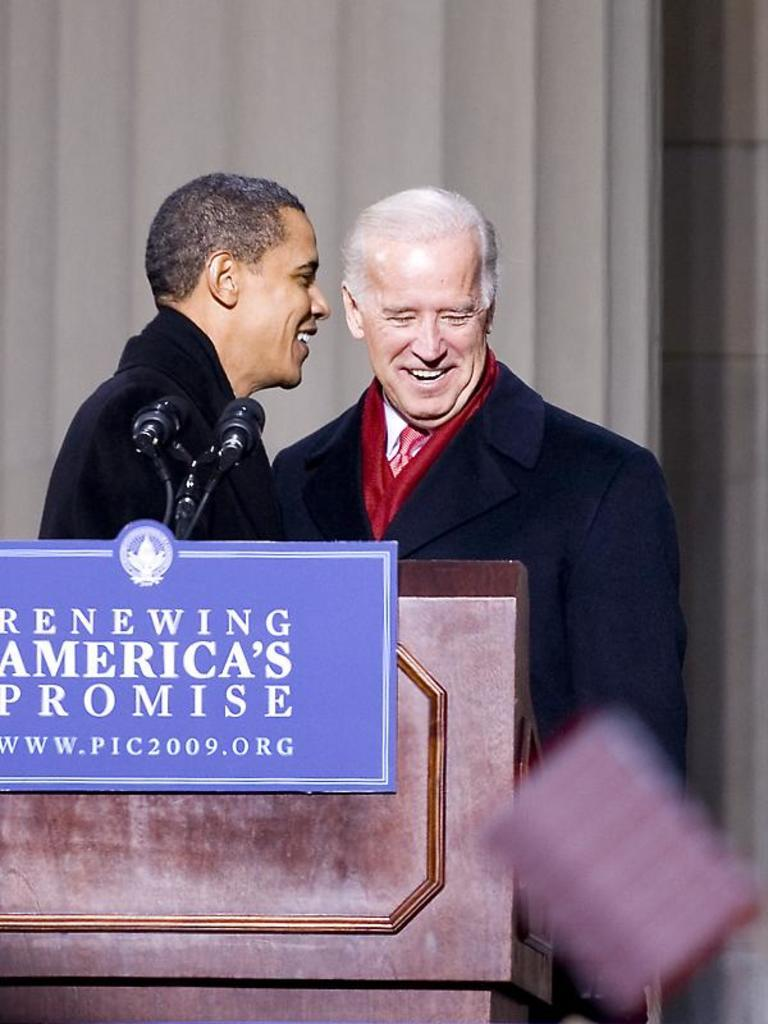How many people are in the image? There are two men in the image. What are the men doing in the image? The men are standing behind a podium. What is on the podium? There is a name plate and a microphone on the podium. What can be seen behind the men? There is a wall behind the men. What type of art is displayed on the wall behind the men? There is no art displayed on the wall behind the men in the image. How does the cough of the man on the left affect the speech being given? There is no indication of a cough or speech being given in the image. 